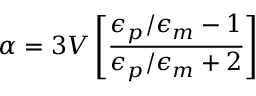<formula> <loc_0><loc_0><loc_500><loc_500>\alpha = 3 V \left [ { \frac { \epsilon _ { p } / \epsilon _ { m } - 1 } { \epsilon _ { p } / \epsilon _ { m } + 2 } } \right ]</formula> 